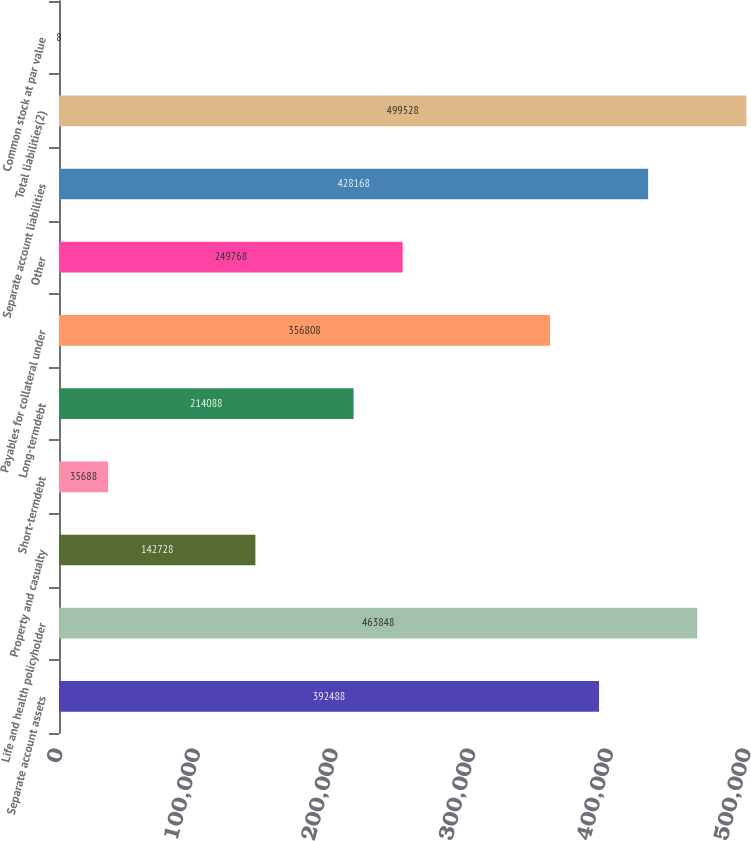<chart> <loc_0><loc_0><loc_500><loc_500><bar_chart><fcel>Separate account assets<fcel>Life and health policyholder<fcel>Property and casualty<fcel>Short-termdebt<fcel>Long-termdebt<fcel>Payables for collateral under<fcel>Other<fcel>Separate account liabilities<fcel>Total liabilities(2)<fcel>Common stock at par value<nl><fcel>392488<fcel>463848<fcel>142728<fcel>35688<fcel>214088<fcel>356808<fcel>249768<fcel>428168<fcel>499528<fcel>8<nl></chart> 